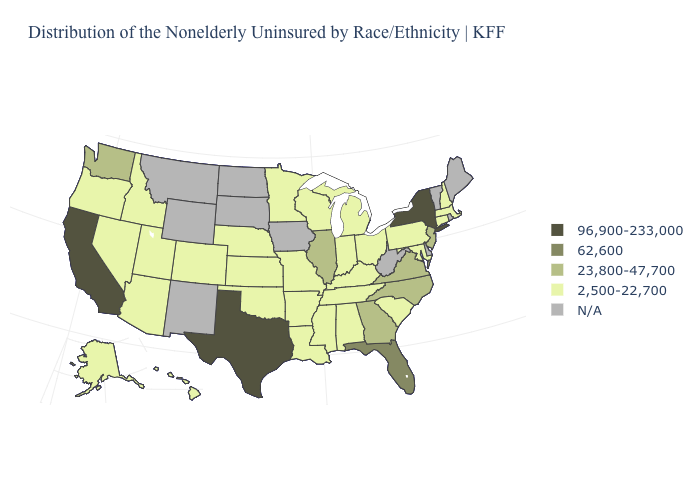What is the lowest value in states that border Washington?
Quick response, please. 2,500-22,700. Which states have the highest value in the USA?
Write a very short answer. California, New York, Texas. What is the value of Maryland?
Answer briefly. 2,500-22,700. Name the states that have a value in the range 62,600?
Answer briefly. Florida. Does North Carolina have the highest value in the South?
Quick response, please. No. Name the states that have a value in the range 23,800-47,700?
Quick response, please. Georgia, Illinois, New Jersey, North Carolina, Virginia, Washington. Does Florida have the highest value in the USA?
Short answer required. No. Which states have the highest value in the USA?
Answer briefly. California, New York, Texas. What is the value of Illinois?
Give a very brief answer. 23,800-47,700. What is the lowest value in the South?
Answer briefly. 2,500-22,700. Does Illinois have the highest value in the MidWest?
Quick response, please. Yes. Name the states that have a value in the range N/A?
Be succinct. Delaware, Iowa, Maine, Montana, New Mexico, North Dakota, Rhode Island, South Dakota, Vermont, West Virginia, Wyoming. 